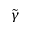<formula> <loc_0><loc_0><loc_500><loc_500>\tilde { \gamma }</formula> 